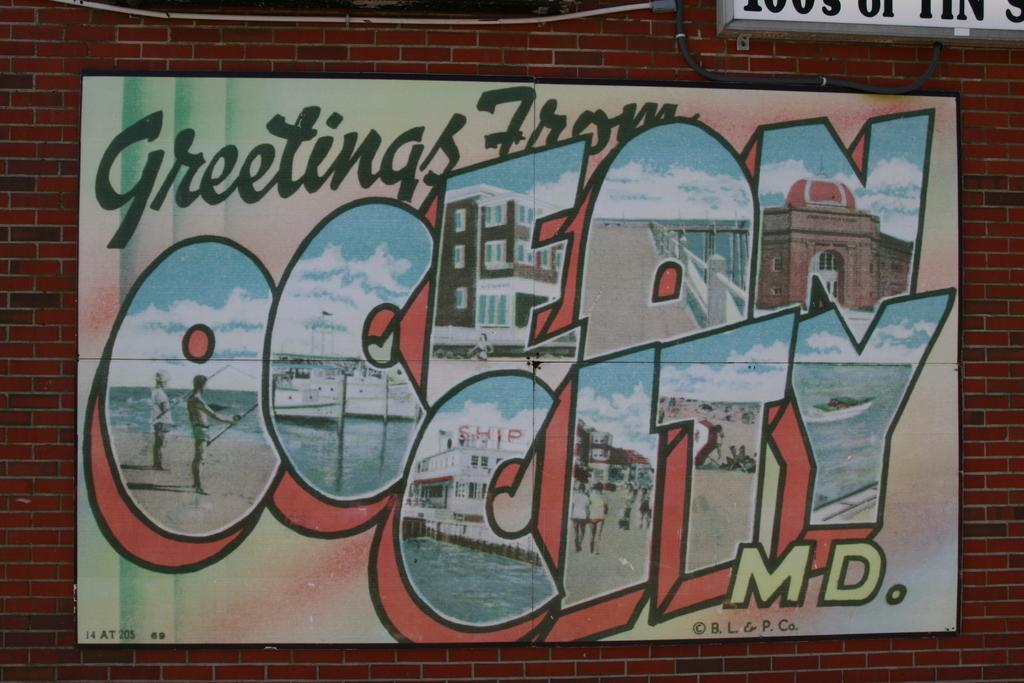Provide a one-sentence caption for the provided image. A building hosts a post card like advertisement for Ocean City Maryland. 